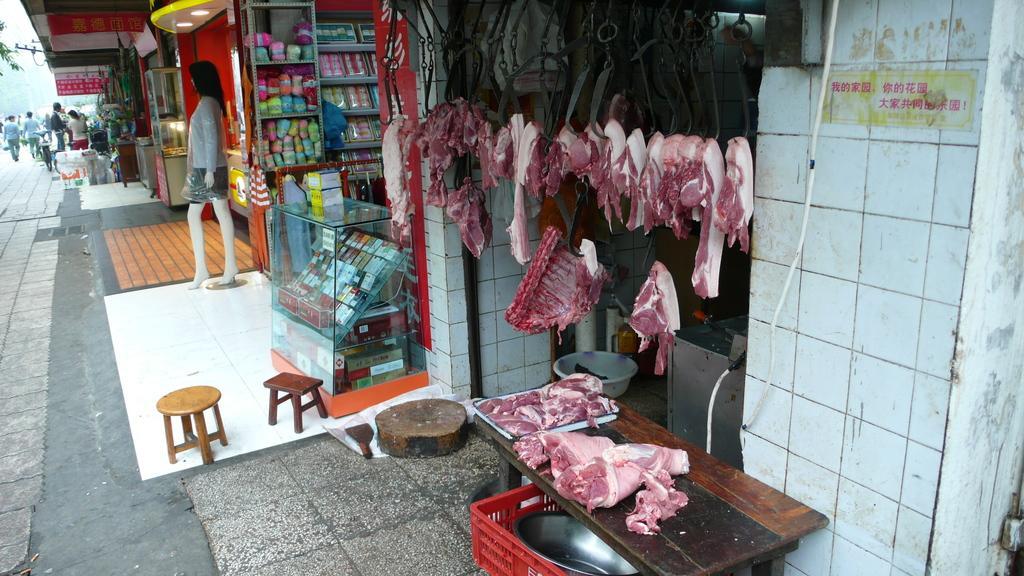Can you describe this image briefly? In this picture I can observe meat store on the right side. I can observe some other stores in the middle of the picture. There is a mannequin on the left side. 